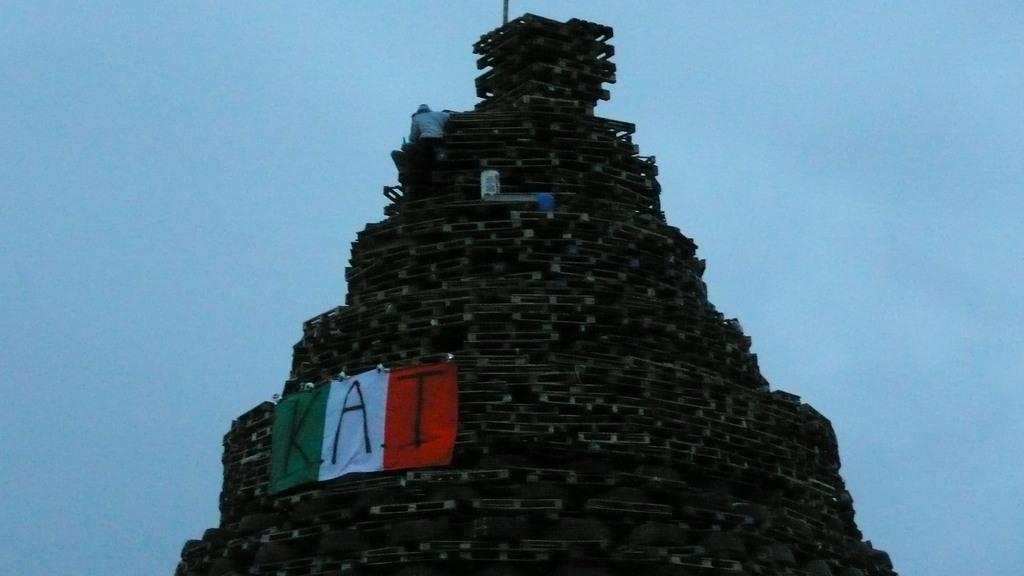What type of structure can be seen in the image? There is a structure in the image that resembles a Hindu temple. What is covering the structure? There is a cloth on the structure. What is written or depicted on the cloth? Text is written on the cloth. Is there anyone present on the structure? Yes, there is a person on the structure. What type of gun is being used by the person on the structure? There is no gun present in the image; the person on the structure is not depicted with any weapon. 